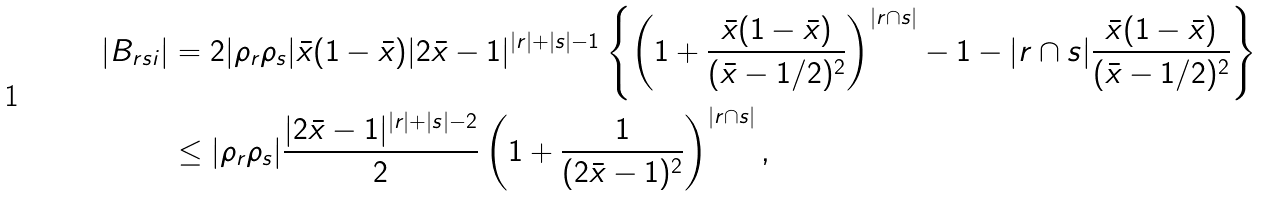Convert formula to latex. <formula><loc_0><loc_0><loc_500><loc_500>| B _ { r s i } | & = 2 | \rho _ { r } \rho _ { s } | \bar { x } ( 1 - \bar { x } ) | 2 \bar { x } - 1 | ^ { | r | + | s | - 1 } \left \{ \left ( 1 + \frac { \bar { x } ( 1 - \bar { x } ) } { ( \bar { x } - 1 / 2 ) ^ { 2 } } \right ) ^ { | r \cap s | } - 1 - | r \cap s | \frac { \bar { x } ( 1 - \bar { x } ) } { ( \bar { x } - 1 / 2 ) ^ { 2 } } \right \} \\ & \leq | \rho _ { r } \rho _ { s } | \frac { | 2 \bar { x } - 1 | ^ { | r | + | s | - 2 } } { 2 } \left ( 1 + \frac { 1 } { ( 2 \bar { x } - 1 ) ^ { 2 } } \right ) ^ { | r \cap s | } ,</formula> 